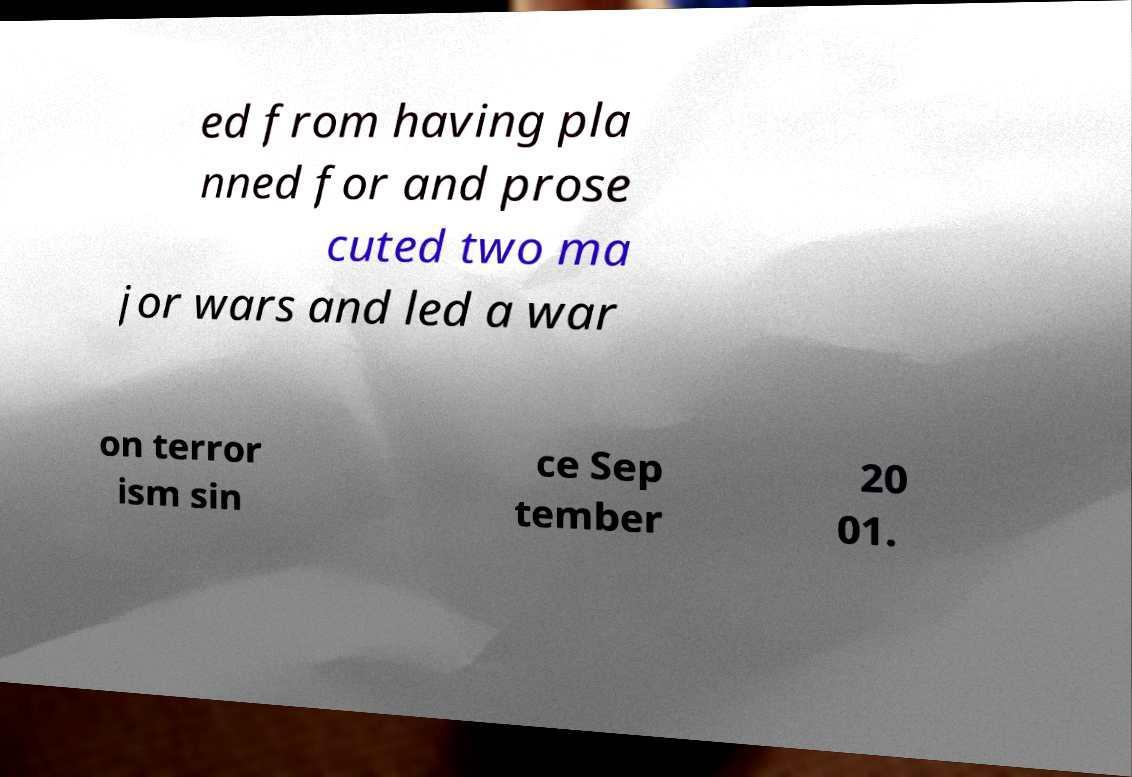Could you assist in decoding the text presented in this image and type it out clearly? ed from having pla nned for and prose cuted two ma jor wars and led a war on terror ism sin ce Sep tember 20 01. 